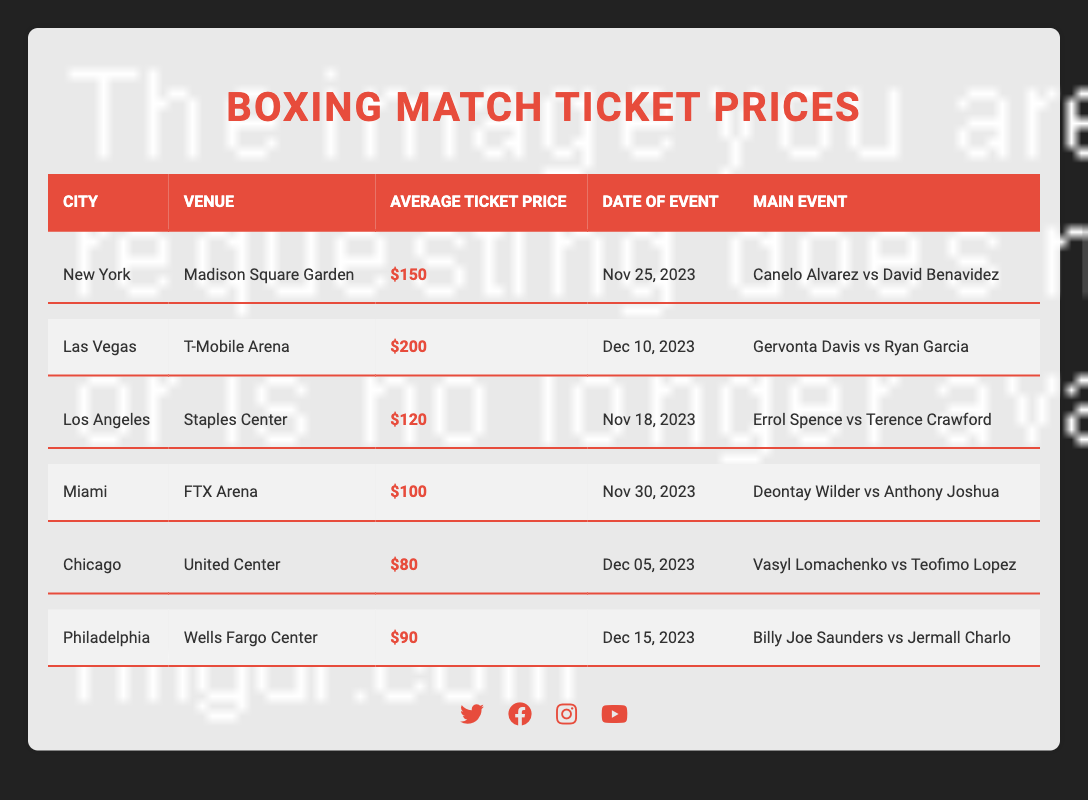What is the average ticket price for boxing matches in New York? The average ticket price for the event in New York, listed under "Madison Square Garden," is explicitly shown in the table as $150.
Answer: $150 Which city has the highest average ticket price? By comparing the average ticket prices listed for each city, Las Vegas has the highest price at $200, while all others are lower.
Answer: Las Vegas How much cheaper is a ticket in Chicago compared to Miami? The average ticket price in Chicago is $80, and in Miami, it is $100. To find the difference, subtract the price in Chicago from the price in Miami: $100 - $80 = $20.
Answer: $20 What are the two boxers fighting in Los Angeles? Referring to the event listed for Los Angeles in the "Staples Center," the boxers are Errol Spence and Terence Crawford.
Answer: Errol Spence and Terence Crawford Is the average ticket price for the match in Philadelphia lower than $100? The average ticket price in Philadelphia is $90, which is indeed lower than $100, confirming the statement is true.
Answer: Yes Which event takes place closest to the end of the year and what is its average ticket price? The event occurring closest to the end of the year is in Philadelphia on December 15, 2023, with an average ticket price of $90.
Answer: $90 What is the combined average ticket price for the events in Miami and Chicago? The average ticket prices in Miami and Chicago are $100 and $80 respectively. Adding these gives: $100 + $80 = $180. To find the average, divide by 2: $180 / 2 = $90.
Answer: $90 What venue hosts the match between Canelo Alvarez and David Benavidez? The venue for the match between Canelo Alvarez and David Benavidez, as listed for New York on November 25, is Madison Square Garden.
Answer: Madison Square Garden Which boxer is featured in the least expensive match, and what is the price? The least expensive match is in Chicago featuring Vasyl Lomachenko and Teofimo Lopez, with an average ticket price of $80, which is the lowest in the table.
Answer: Vasyl Lomachenko, $80 How many cities have average ticket prices above $100? By inspecting the table, the cities with ticket prices above $100 are Las Vegas ($200), New York ($150), and Los Angeles ($120). Counting these gives a total of 3 cities.
Answer: 3 If you wanted to attend a match in Miami, how much money would you save compared to attending a match in Las Vegas? The average ticket price for Miami is $100, and for Las Vegas, it is $200. The amount saved would be: $200 - $100 = $100.
Answer: $100 